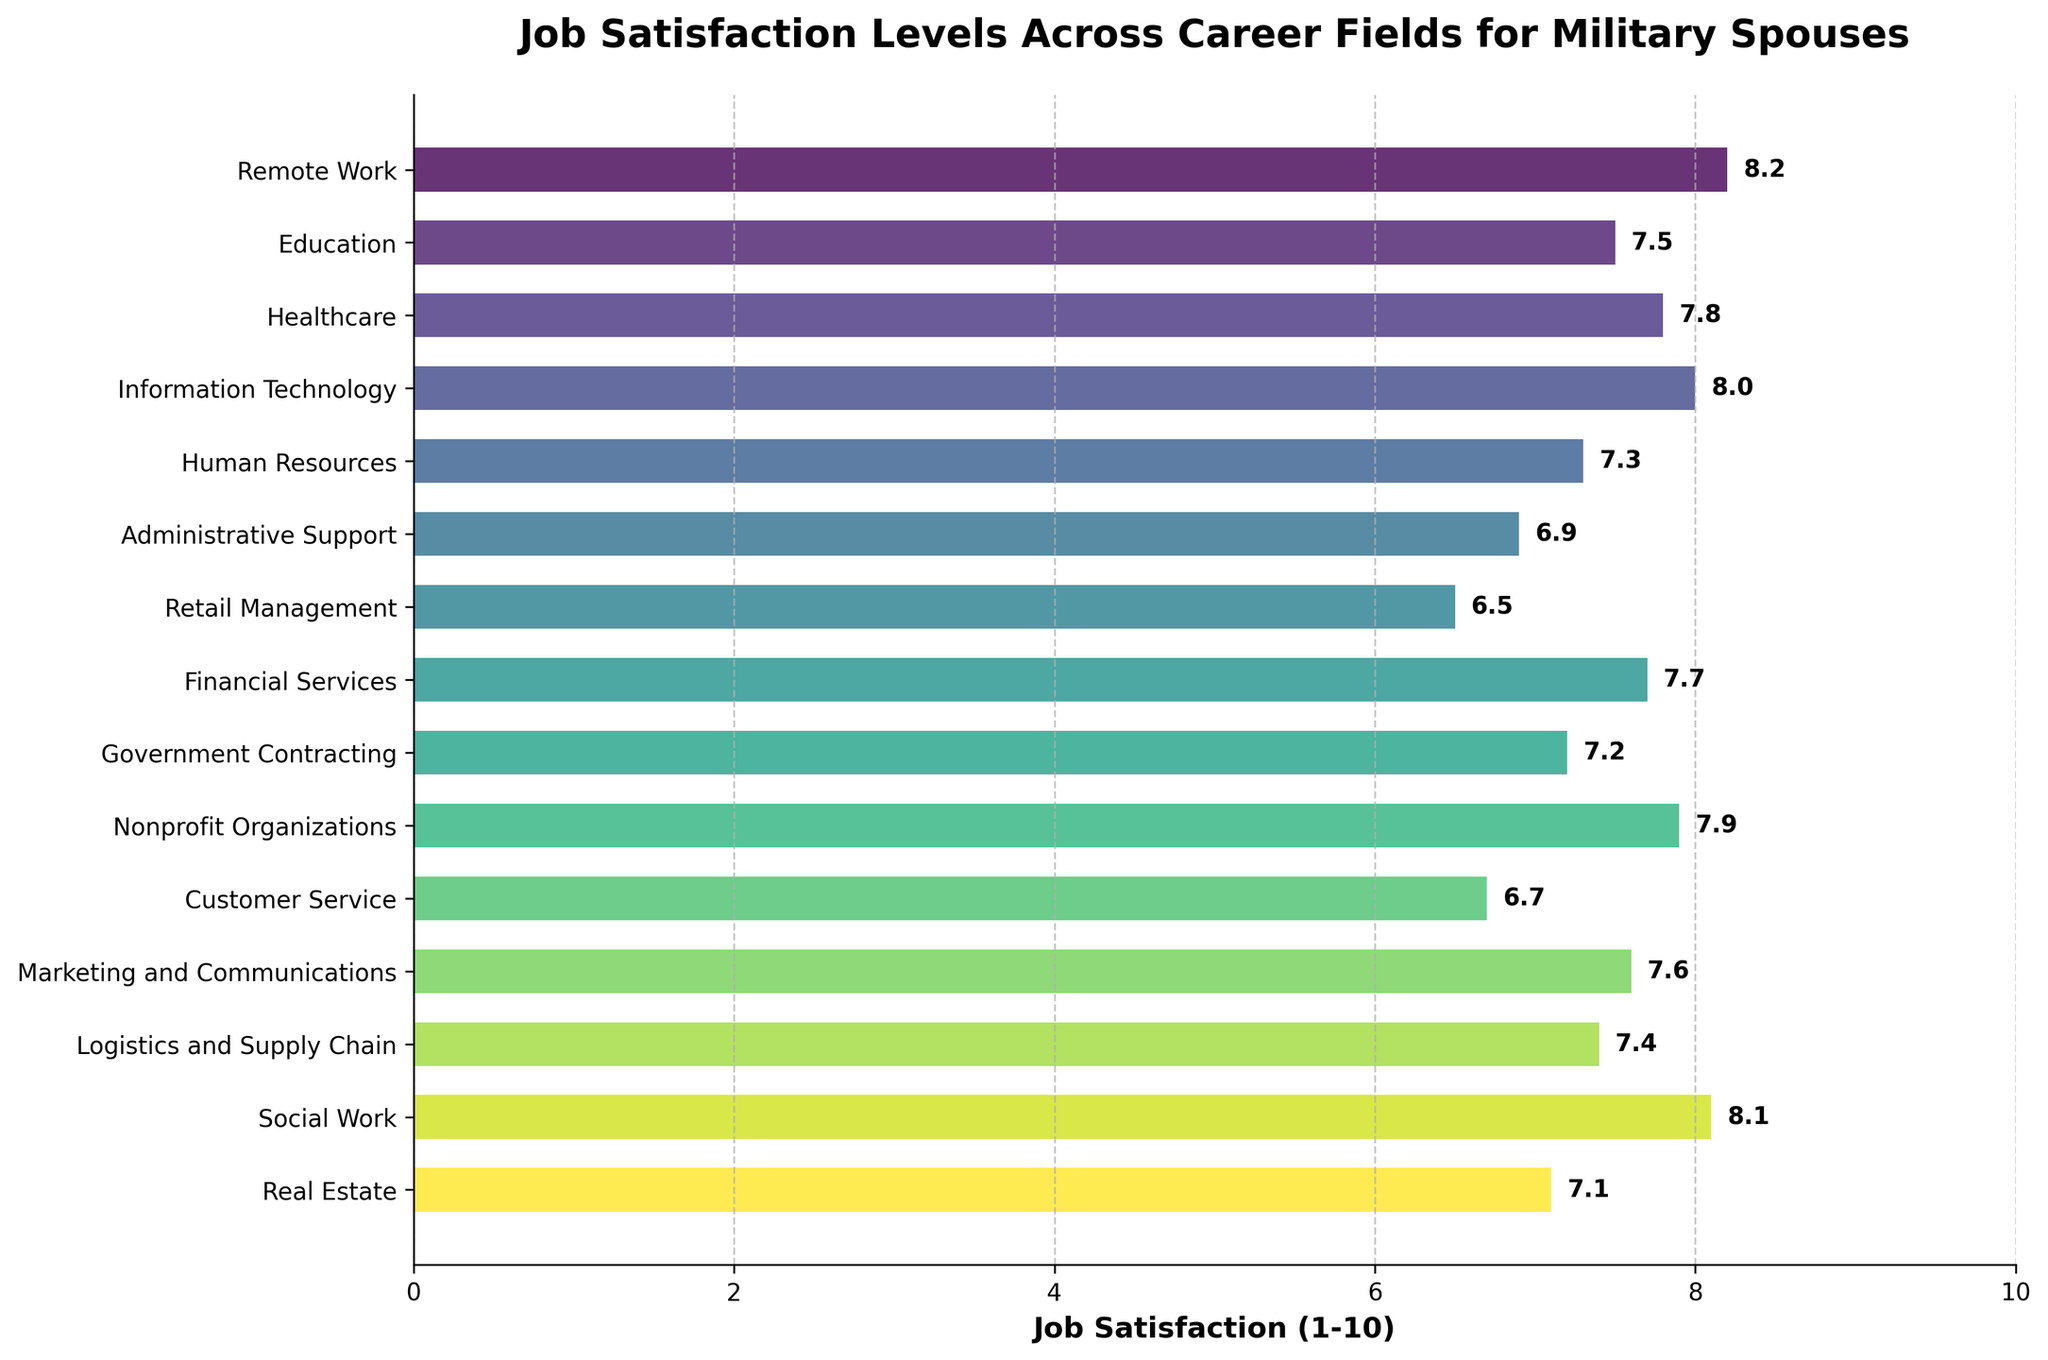Which career field has the highest job satisfaction? The bar representing the "Remote Work" field is the longest, indicating the highest job satisfaction.
Answer: Remote Work Which career field has the lowest job satisfaction? The bar representing "Retail Management" is the shortest, indicating the lowest job satisfaction.
Answer: Retail Management How does job satisfaction in Information Technology compare to that in Healthcare? The bar for Information Technology is slightly longer than the bar for Healthcare, indicating higher job satisfaction.
Answer: Higher What is the difference in job satisfaction between the highest and lowest career fields? The highest job satisfaction is 8.2 (Remote Work) and the lowest is 6.5 (Retail Management). The difference is 8.2 - 6.5.
Answer: 1.7 Are there any career fields with job satisfaction equal to 7.5? The bar for Education aligns with 7.5 on the x-axis.
Answer: Education What is the average job satisfaction across all career fields? Sum all the job satisfaction scores and divide by the number of fields: (8.2 + 7.5 + 7.8 + 8.0 + 7.3 + 6.9 + 6.5 + 7.7 + 7.2 + 7.9 + 6.7 + 7.6 + 7.4 + 8.1 + 7.1) / 15 = 7.48
Answer: 7.48 Which career fields have a job satisfaction above 8? Bars representing Remote Work, Information Technology, and Social Work exceed the 8 mark.
Answer: Remote Work, Information Technology, Social Work Is job satisfaction in Financial Services higher or lower than in Nonprofit Organizations? The bar for Nonprofit Organizations is slightly longer than the bar for Financial Services, indicating higher satisfaction.
Answer: Lower How many career fields have job satisfaction above the overall average? First, calculate the average job satisfaction: 7.48. Count the fields with scores above this average. Fields: Remote Work, Information Technology, Social Work, Nonprofit Organizations.
Answer: 4 What is the median job satisfaction value? Arrange the values in order: 6.5, 6.7, 6.9, 7.1, 7.2, 7.3, 7.4, 7.5, 7.6, 7.7, 7.8, 7.9, 8.0, 8.1, 8.2. The median is the middle value.
Answer: 7.5 